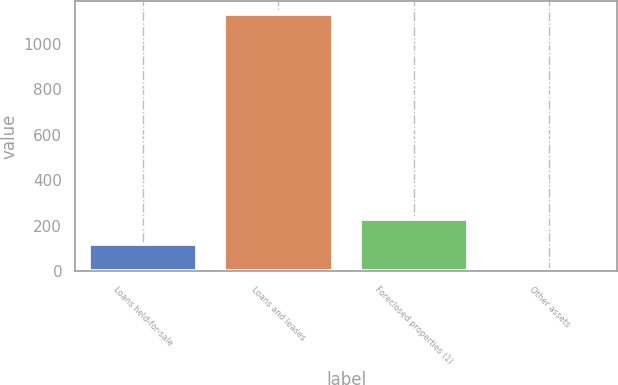<chart> <loc_0><loc_0><loc_500><loc_500><bar_chart><fcel>Loans held-for-sale<fcel>Loans and leases<fcel>Foreclosed properties (1)<fcel>Other assets<nl><fcel>118.6<fcel>1132<fcel>231.2<fcel>6<nl></chart> 